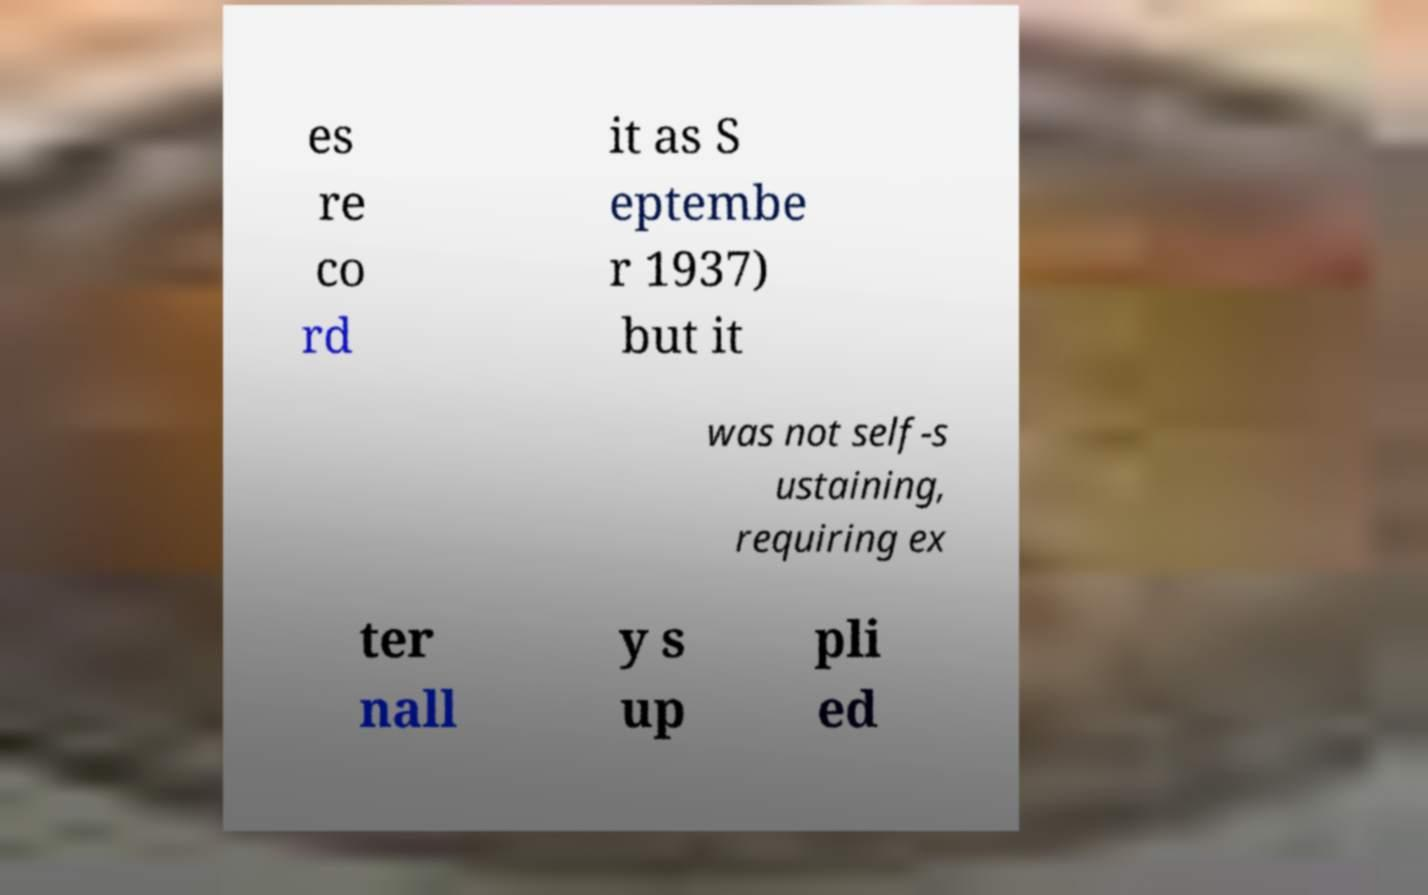I need the written content from this picture converted into text. Can you do that? es re co rd it as S eptembe r 1937) but it was not self-s ustaining, requiring ex ter nall y s up pli ed 